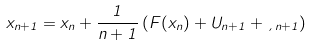Convert formula to latex. <formula><loc_0><loc_0><loc_500><loc_500>x _ { n + 1 } = x _ { n } + \frac { 1 } { n + 1 } \left ( F ( x _ { n } ) + U _ { n + 1 } + \xi _ { n + 1 } \right )</formula> 